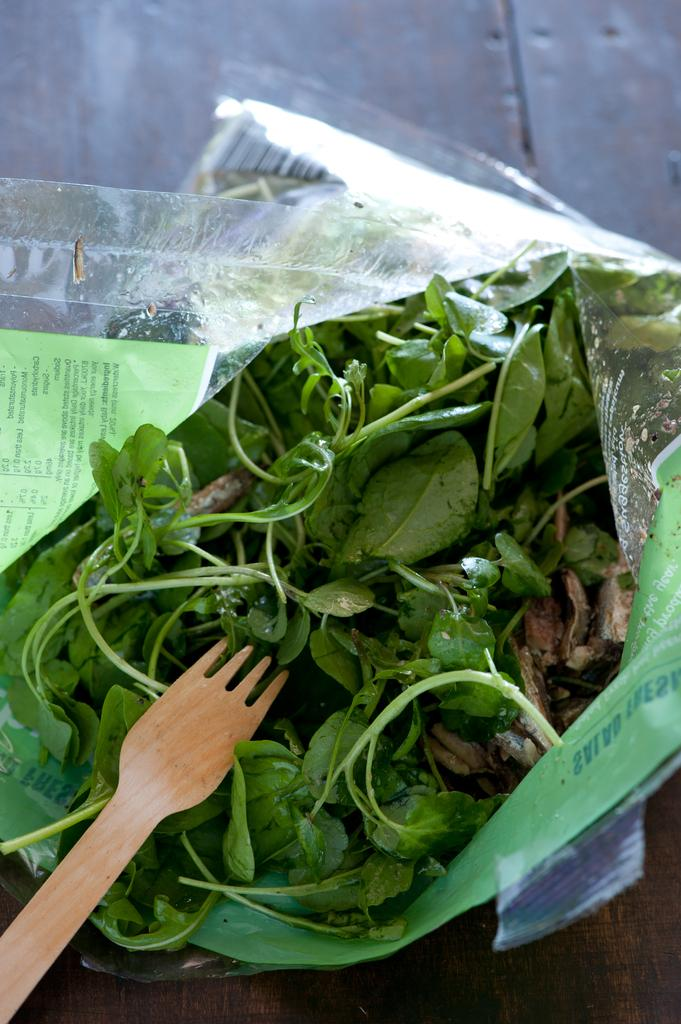What type of food items are in the plastic bag in the image? There are vegetables in a plastic bag in the image. What utensil can be seen in the image? There is a wooden spoon in the image. What type of jewel is the vegetable wearing in the image? There is no indication that the vegetables are wearing any type of jewel in the image. How does the wooden spoon breathe in the image? The wooden spoon does not breathe in the image, as it is an inanimate object. 